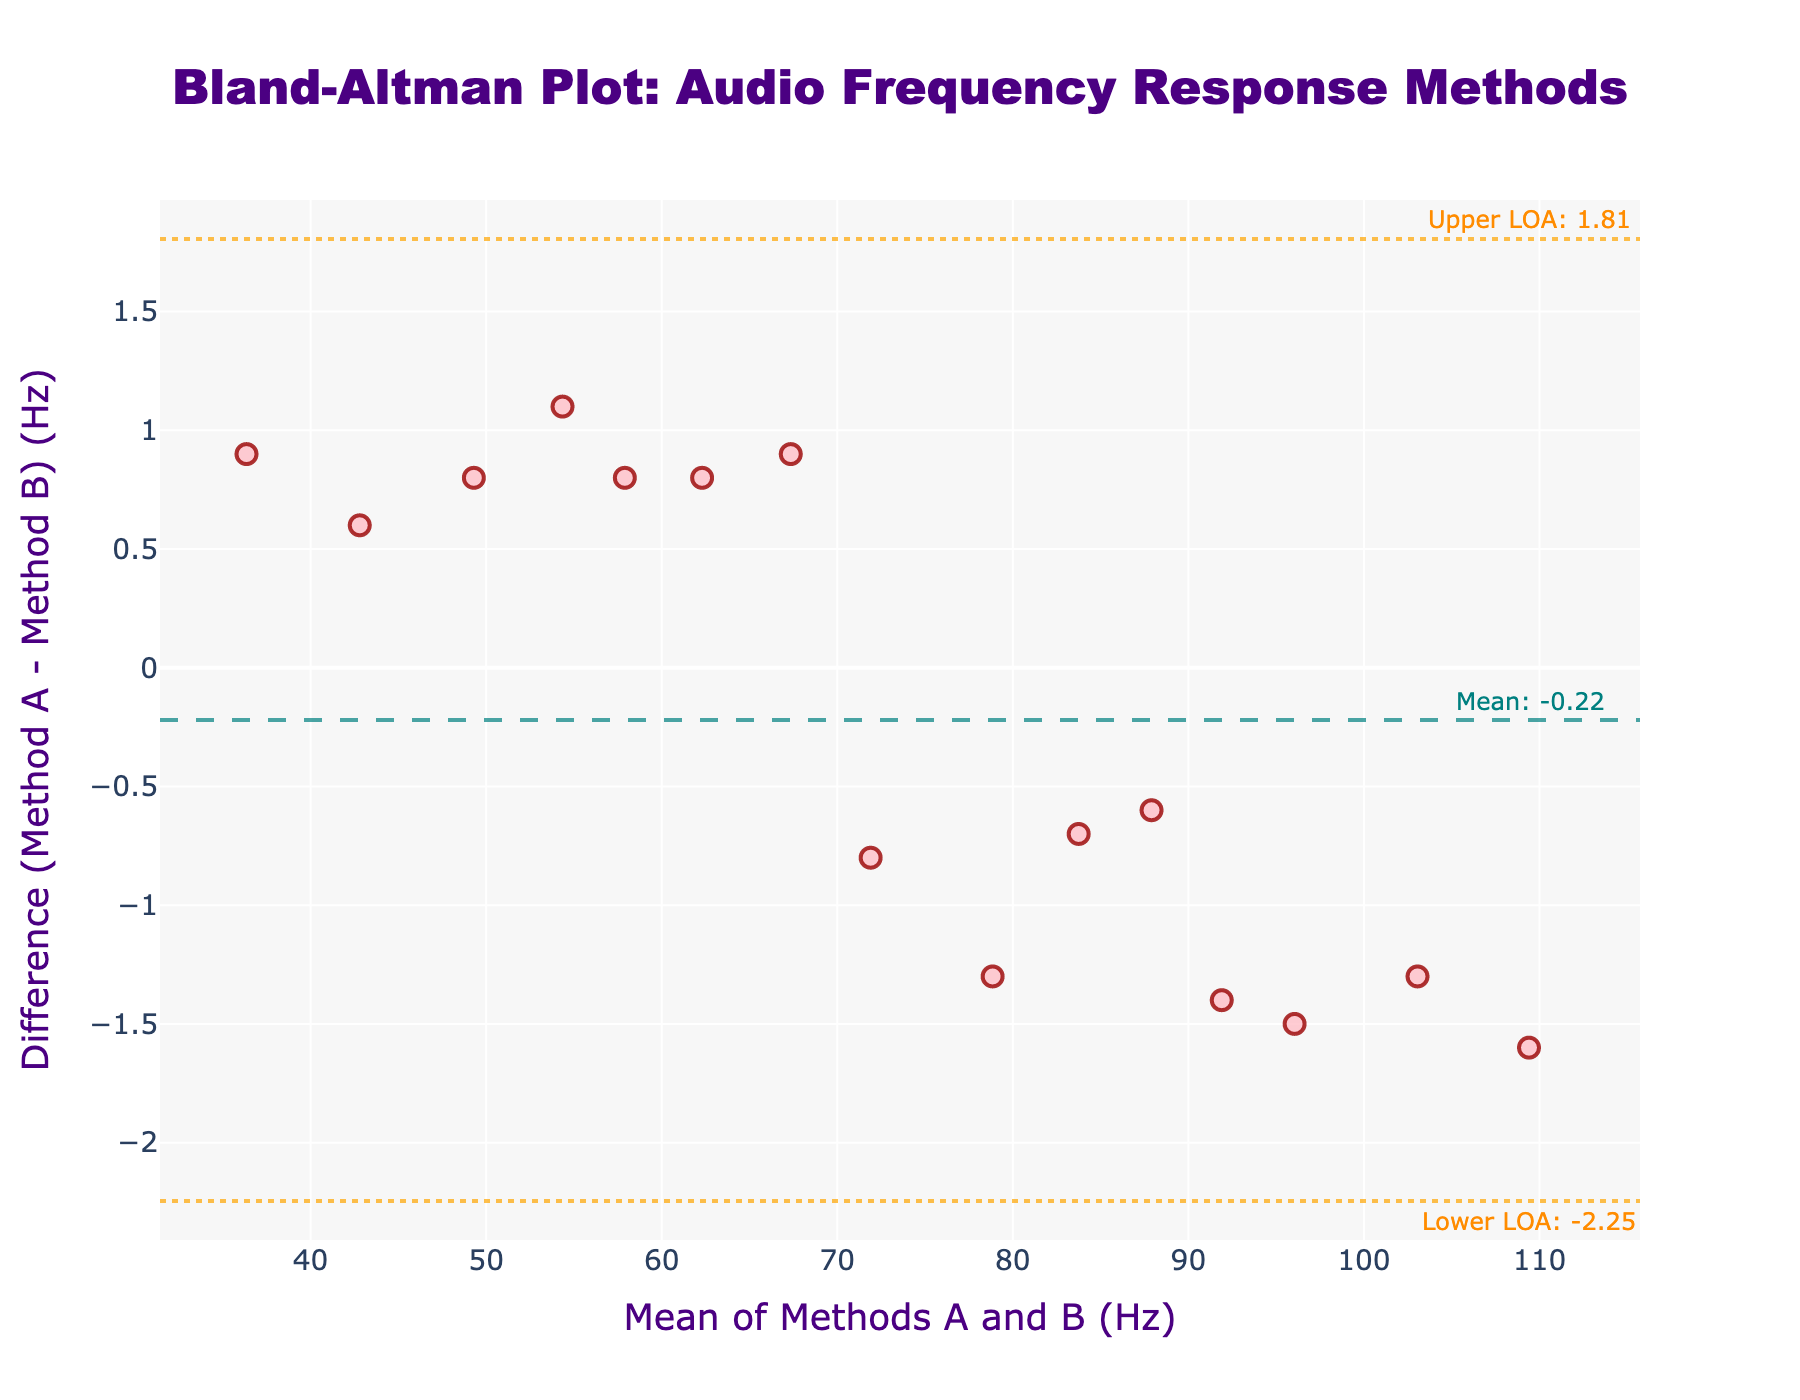What's the title of the plot? The title of the plot is located at the top center, in a large font, and it specifies what the plot is representing using a descriptive text.
Answer: Bland-Altman Plot: Audio Frequency Response Methods How many data points are represented in the scatter plot? Each scatter point represents a pair of frequency measurements from Method A and Method B. By counting all individual markers or entries, you can determine the number of data points.
Answer: 15 What is the mean difference between the two methods of measurement? The mean difference is indicated by a horizontal dashed line across the plot. An annotation on this line shows the exact numerical value of the mean difference.
Answer: 0.55 Hz What colors are used for the upper and lower limits of agreement lines? There are horizontal dotted lines in the plot, distinguishing themselves by their unique color. These lines mark the upper and lower limits of agreement. Their color is consistent with the annotation text's color mentioning the upper and lower LoA.
Answer: Orange Compare the highest and lowest mean values of the measurements. What's the difference? The highest and lowest mean values can be found along the x-axis by identifying the extreme points of the data cloud. The difference is calculated by subtracting the lowest mean value from the highest mean value.
Answer: 72.9 Hz What would you conclude if most data points fall within the limits of agreement? By observing the distribution of data points relative to the upper and lower LoA lines, you can determine if the points mostly fall within the boundaries. This scenario typically indicates good agreement between the two measurement methods.
Answer: The methods agree well Is there any point lying exactly at the mean difference line? The mean difference line is a dashed line at a specific y-value. By visually inspecting if any scatter points lie exactly on this line, you can determine if such a point exists.
Answer: No What is the range of the difference values? The range of the difference values can be determined by identifying the highest and lowest y-values of the scatter points on the plot. The range is calculated by subtracting the smallest difference from the largest difference.
Answer: 3.4 Hz (from -1.7 to 1.7 Hz) 